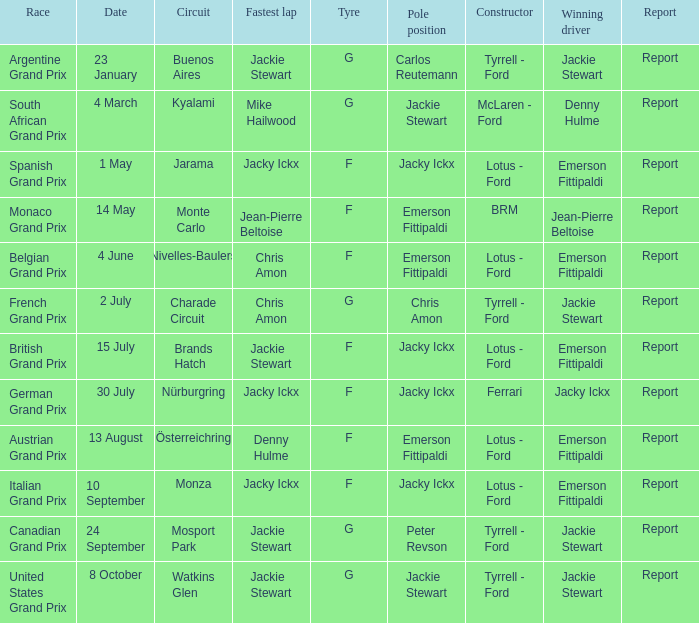What day did Emerson Fittipaldi win the Spanish Grand Prix? 1 May. 